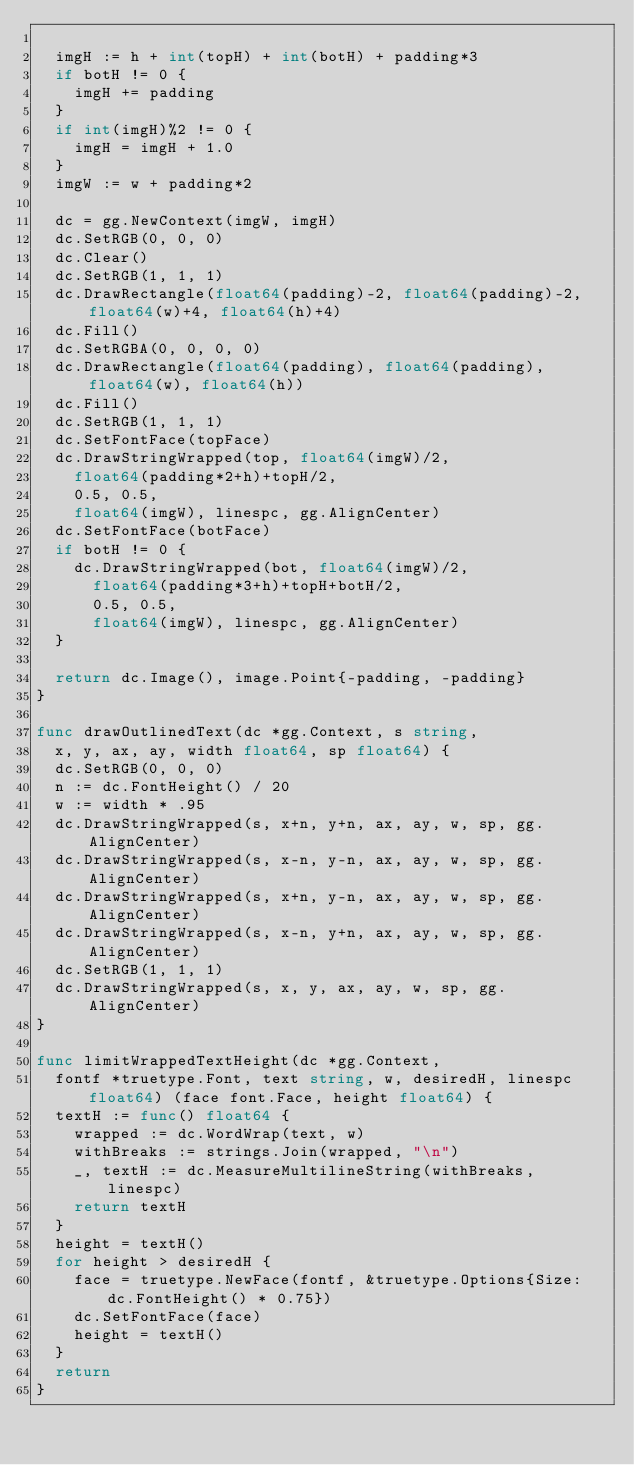<code> <loc_0><loc_0><loc_500><loc_500><_Go_>
	imgH := h + int(topH) + int(botH) + padding*3
	if botH != 0 {
		imgH += padding
	}
	if int(imgH)%2 != 0 {
		imgH = imgH + 1.0
	}
	imgW := w + padding*2

	dc = gg.NewContext(imgW, imgH)
	dc.SetRGB(0, 0, 0)
	dc.Clear()
	dc.SetRGB(1, 1, 1)
	dc.DrawRectangle(float64(padding)-2, float64(padding)-2, float64(w)+4, float64(h)+4)
	dc.Fill()
	dc.SetRGBA(0, 0, 0, 0)
	dc.DrawRectangle(float64(padding), float64(padding), float64(w), float64(h))
	dc.Fill()
	dc.SetRGB(1, 1, 1)
	dc.SetFontFace(topFace)
	dc.DrawStringWrapped(top, float64(imgW)/2,
		float64(padding*2+h)+topH/2,
		0.5, 0.5,
		float64(imgW), linespc, gg.AlignCenter)
	dc.SetFontFace(botFace)
	if botH != 0 {
		dc.DrawStringWrapped(bot, float64(imgW)/2,
			float64(padding*3+h)+topH+botH/2,
			0.5, 0.5,
			float64(imgW), linespc, gg.AlignCenter)
	}

	return dc.Image(), image.Point{-padding, -padding}
}

func drawOutlinedText(dc *gg.Context, s string,
	x, y, ax, ay, width float64, sp float64) {
	dc.SetRGB(0, 0, 0)
	n := dc.FontHeight() / 20
	w := width * .95
	dc.DrawStringWrapped(s, x+n, y+n, ax, ay, w, sp, gg.AlignCenter)
	dc.DrawStringWrapped(s, x-n, y-n, ax, ay, w, sp, gg.AlignCenter)
	dc.DrawStringWrapped(s, x+n, y-n, ax, ay, w, sp, gg.AlignCenter)
	dc.DrawStringWrapped(s, x-n, y+n, ax, ay, w, sp, gg.AlignCenter)
	dc.SetRGB(1, 1, 1)
	dc.DrawStringWrapped(s, x, y, ax, ay, w, sp, gg.AlignCenter)
}

func limitWrappedTextHeight(dc *gg.Context,
	fontf *truetype.Font, text string, w, desiredH, linespc float64) (face font.Face, height float64) {
	textH := func() float64 {
		wrapped := dc.WordWrap(text, w)
		withBreaks := strings.Join(wrapped, "\n")
		_, textH := dc.MeasureMultilineString(withBreaks, linespc)
		return textH
	}
	height = textH()
	for height > desiredH {
		face = truetype.NewFace(fontf, &truetype.Options{Size: dc.FontHeight() * 0.75})
		dc.SetFontFace(face)
		height = textH()
	}
	return
}
</code> 